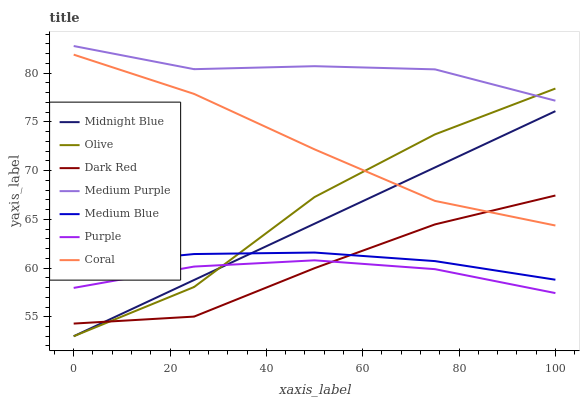Does Purple have the minimum area under the curve?
Answer yes or no. Yes. Does Medium Purple have the maximum area under the curve?
Answer yes or no. Yes. Does Dark Red have the minimum area under the curve?
Answer yes or no. No. Does Dark Red have the maximum area under the curve?
Answer yes or no. No. Is Midnight Blue the smoothest?
Answer yes or no. Yes. Is Olive the roughest?
Answer yes or no. Yes. Is Purple the smoothest?
Answer yes or no. No. Is Purple the roughest?
Answer yes or no. No. Does Midnight Blue have the lowest value?
Answer yes or no. Yes. Does Purple have the lowest value?
Answer yes or no. No. Does Medium Purple have the highest value?
Answer yes or no. Yes. Does Dark Red have the highest value?
Answer yes or no. No. Is Purple less than Coral?
Answer yes or no. Yes. Is Medium Purple greater than Dark Red?
Answer yes or no. Yes. Does Purple intersect Dark Red?
Answer yes or no. Yes. Is Purple less than Dark Red?
Answer yes or no. No. Is Purple greater than Dark Red?
Answer yes or no. No. Does Purple intersect Coral?
Answer yes or no. No. 